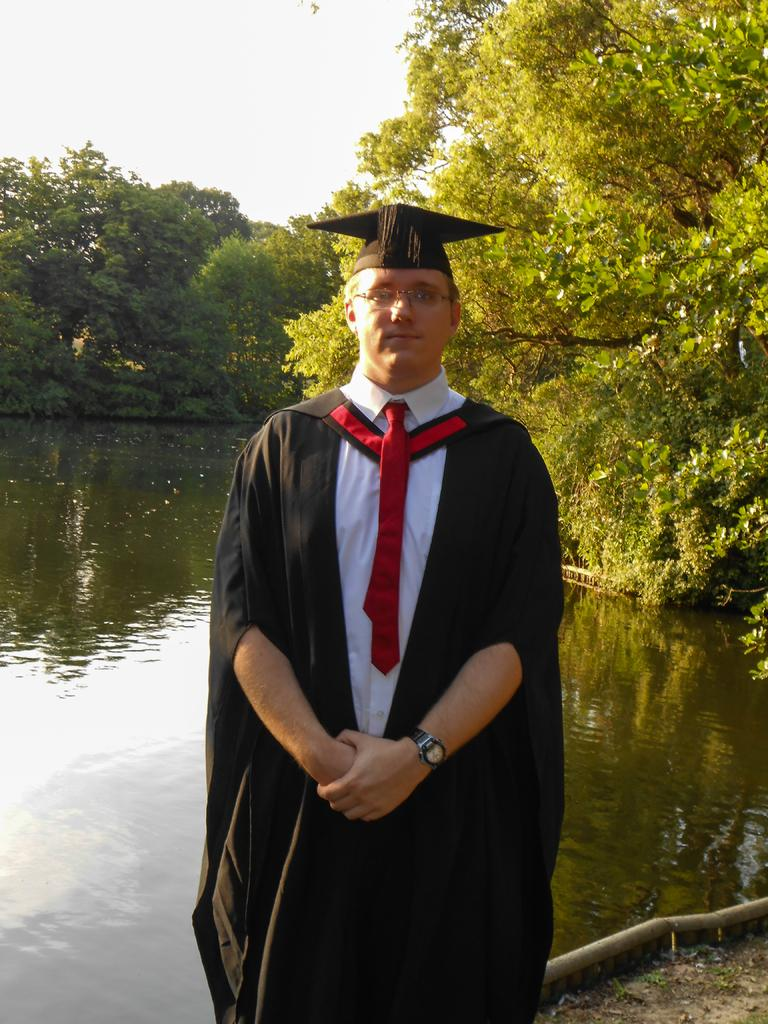What is the person in the image wearing on their face? The person in the image is wearing spectacles. What can be seen beneath the person's feet in the image? The ground is visible in the image. What is the water in the image reflecting? The water in the image has a reflection. What type of vegetation is present in the image? There are trees in the image. What part of the natural environment is visible in the image? The sky is visible in the image. What scent can be detected from the drawer in the image? There is no drawer present in the image, so it is not possible to detect a scent. 